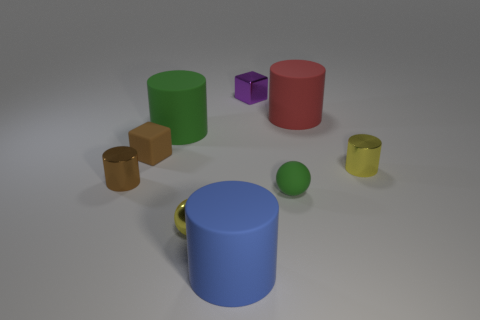Subtract 2 cylinders. How many cylinders are left? 3 Subtract all green cylinders. How many cylinders are left? 4 Subtract all small brown cylinders. How many cylinders are left? 4 Subtract all gray cylinders. Subtract all brown blocks. How many cylinders are left? 5 Add 1 brown shiny objects. How many objects exist? 10 Subtract all balls. How many objects are left? 7 Add 8 tiny yellow things. How many tiny yellow things exist? 10 Subtract 1 brown blocks. How many objects are left? 8 Subtract all cyan cylinders. Subtract all small green things. How many objects are left? 8 Add 3 matte spheres. How many matte spheres are left? 4 